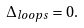<formula> <loc_0><loc_0><loc_500><loc_500>\Delta _ { l o o p s } = 0 .</formula> 